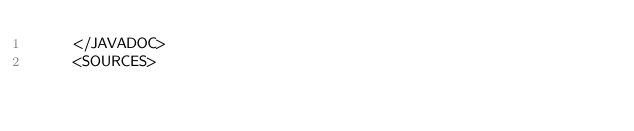Convert code to text. <code><loc_0><loc_0><loc_500><loc_500><_XML_>    </JAVADOC>
    <SOURCES></code> 